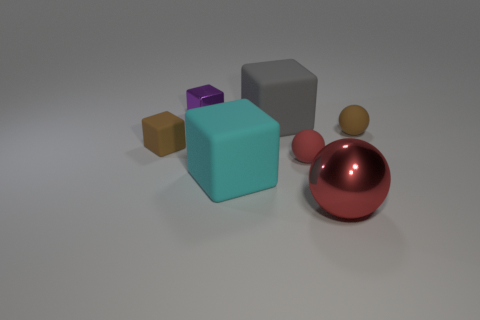There is a small thing that is the same color as the big metallic thing; what shape is it?
Provide a short and direct response. Sphere. What number of other things are the same color as the large sphere?
Keep it short and to the point. 1. How many big shiny objects are there?
Your response must be concise. 1. What material is the brown object that is on the left side of the tiny purple object left of the large sphere?
Offer a terse response. Rubber. There is a purple object that is the same size as the brown sphere; what is its material?
Provide a short and direct response. Metal. There is a metal object that is in front of the brown cube; is its size the same as the red matte sphere?
Provide a succinct answer. No. Does the metal object that is in front of the red matte sphere have the same shape as the tiny red object?
Provide a succinct answer. Yes. How many objects are either small brown metal blocks or balls that are in front of the brown sphere?
Keep it short and to the point. 2. Is the number of spheres less than the number of blue cubes?
Provide a short and direct response. No. Are there more green metallic things than cyan objects?
Your response must be concise. No. 